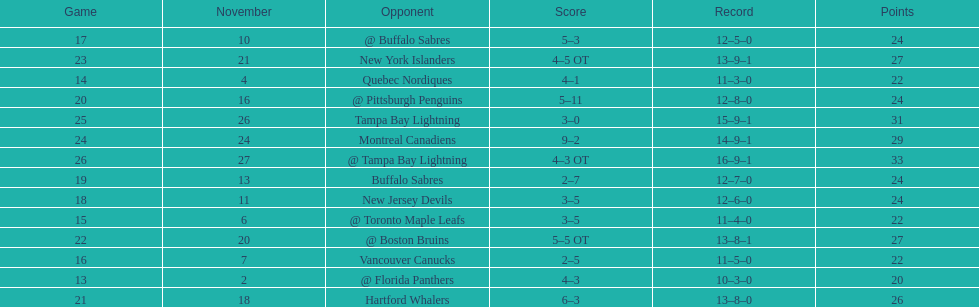Were the new jersey devils in last place according to the chart? No. 